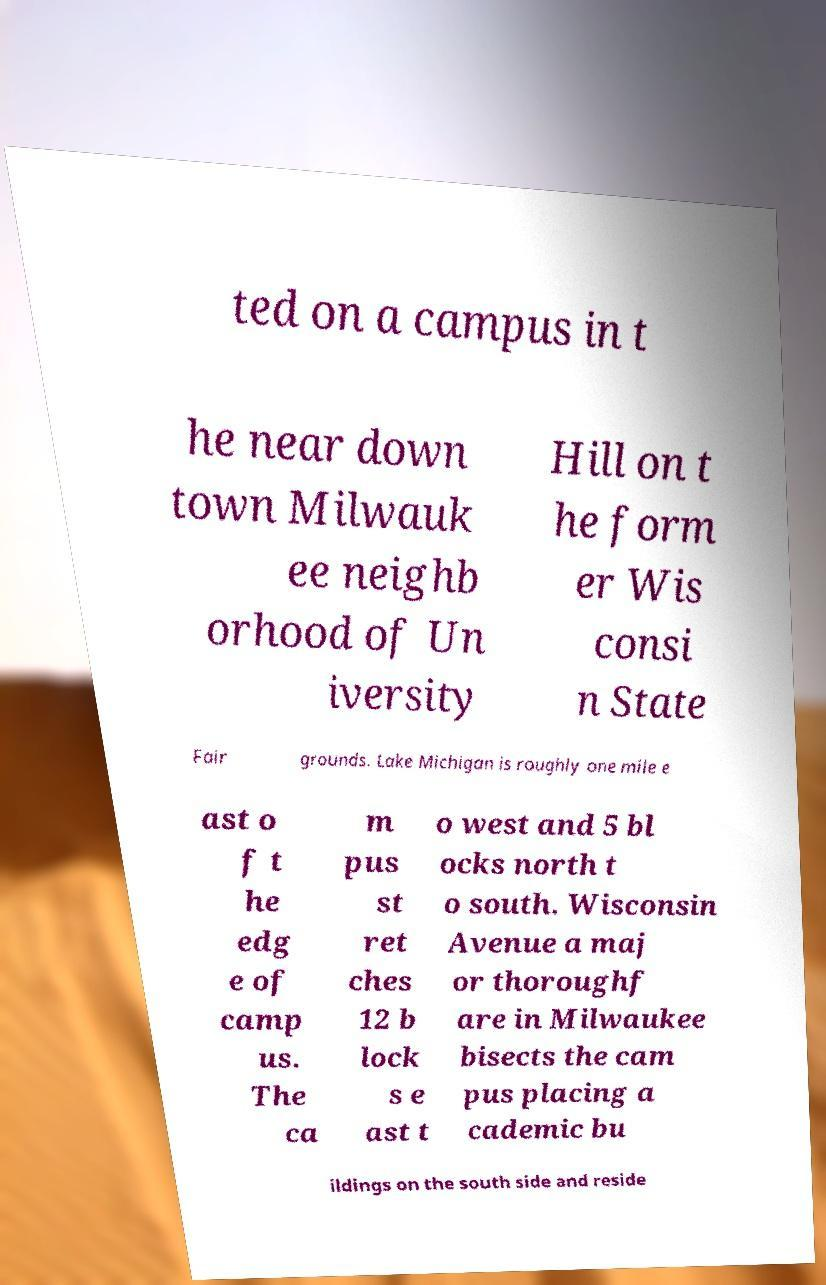Please read and relay the text visible in this image. What does it say? ted on a campus in t he near down town Milwauk ee neighb orhood of Un iversity Hill on t he form er Wis consi n State Fair grounds. Lake Michigan is roughly one mile e ast o f t he edg e of camp us. The ca m pus st ret ches 12 b lock s e ast t o west and 5 bl ocks north t o south. Wisconsin Avenue a maj or thoroughf are in Milwaukee bisects the cam pus placing a cademic bu ildings on the south side and reside 